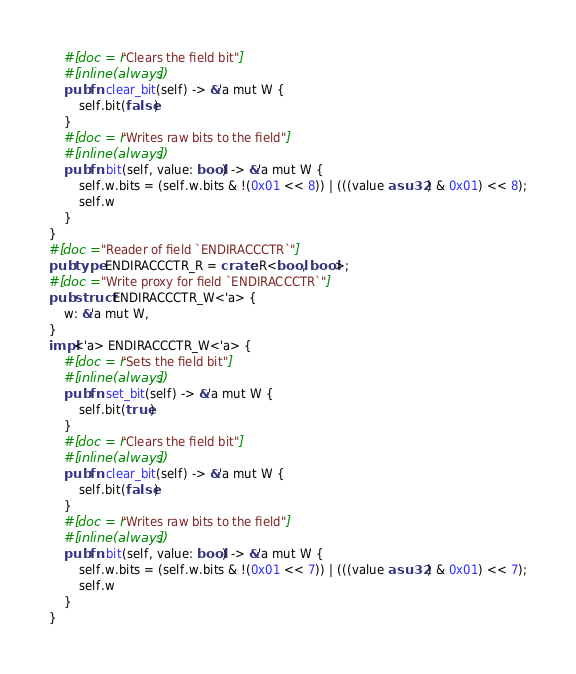<code> <loc_0><loc_0><loc_500><loc_500><_Rust_>    #[doc = r"Clears the field bit"]
    #[inline(always)]
    pub fn clear_bit(self) -> &'a mut W {
        self.bit(false)
    }
    #[doc = r"Writes raw bits to the field"]
    #[inline(always)]
    pub fn bit(self, value: bool) -> &'a mut W {
        self.w.bits = (self.w.bits & !(0x01 << 8)) | (((value as u32) & 0x01) << 8);
        self.w
    }
}
#[doc = "Reader of field `ENDIRACCCTR`"]
pub type ENDIRACCCTR_R = crate::R<bool, bool>;
#[doc = "Write proxy for field `ENDIRACCCTR`"]
pub struct ENDIRACCCTR_W<'a> {
    w: &'a mut W,
}
impl<'a> ENDIRACCCTR_W<'a> {
    #[doc = r"Sets the field bit"]
    #[inline(always)]
    pub fn set_bit(self) -> &'a mut W {
        self.bit(true)
    }
    #[doc = r"Clears the field bit"]
    #[inline(always)]
    pub fn clear_bit(self) -> &'a mut W {
        self.bit(false)
    }
    #[doc = r"Writes raw bits to the field"]
    #[inline(always)]
    pub fn bit(self, value: bool) -> &'a mut W {
        self.w.bits = (self.w.bits & !(0x01 << 7)) | (((value as u32) & 0x01) << 7);
        self.w
    }
}</code> 